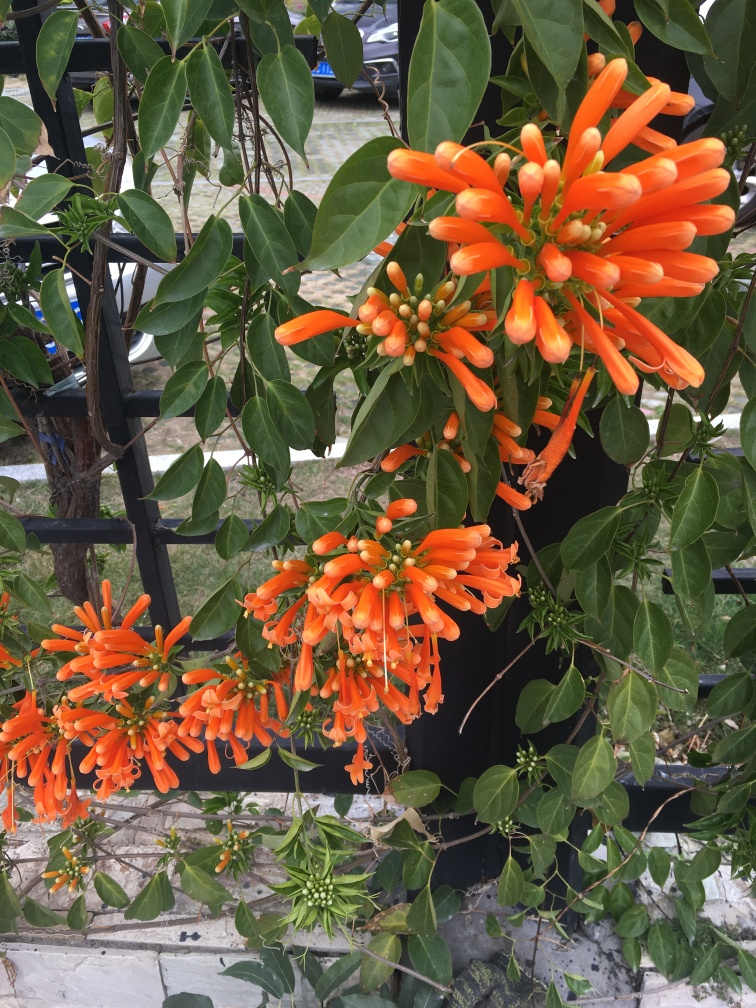This plant looks like it might require some maintenance to keep it under control. Is it considered invasive? While Pyrostegia venusta can be an excellent addition to many gardens, it's fast-growing and spreads quickly, which can lead to it being considered invasive in some regions. It's important for gardeners to manage its growth and be aware of local regulations regarding its cultivation. How would one manage its growth effectively? Regular pruning is essential to control the spread of Pyrostegia venusta. It is recommended to cut back the vines after blooming to maintain the desired shape and prevent it from overtaking other plants or structures. 